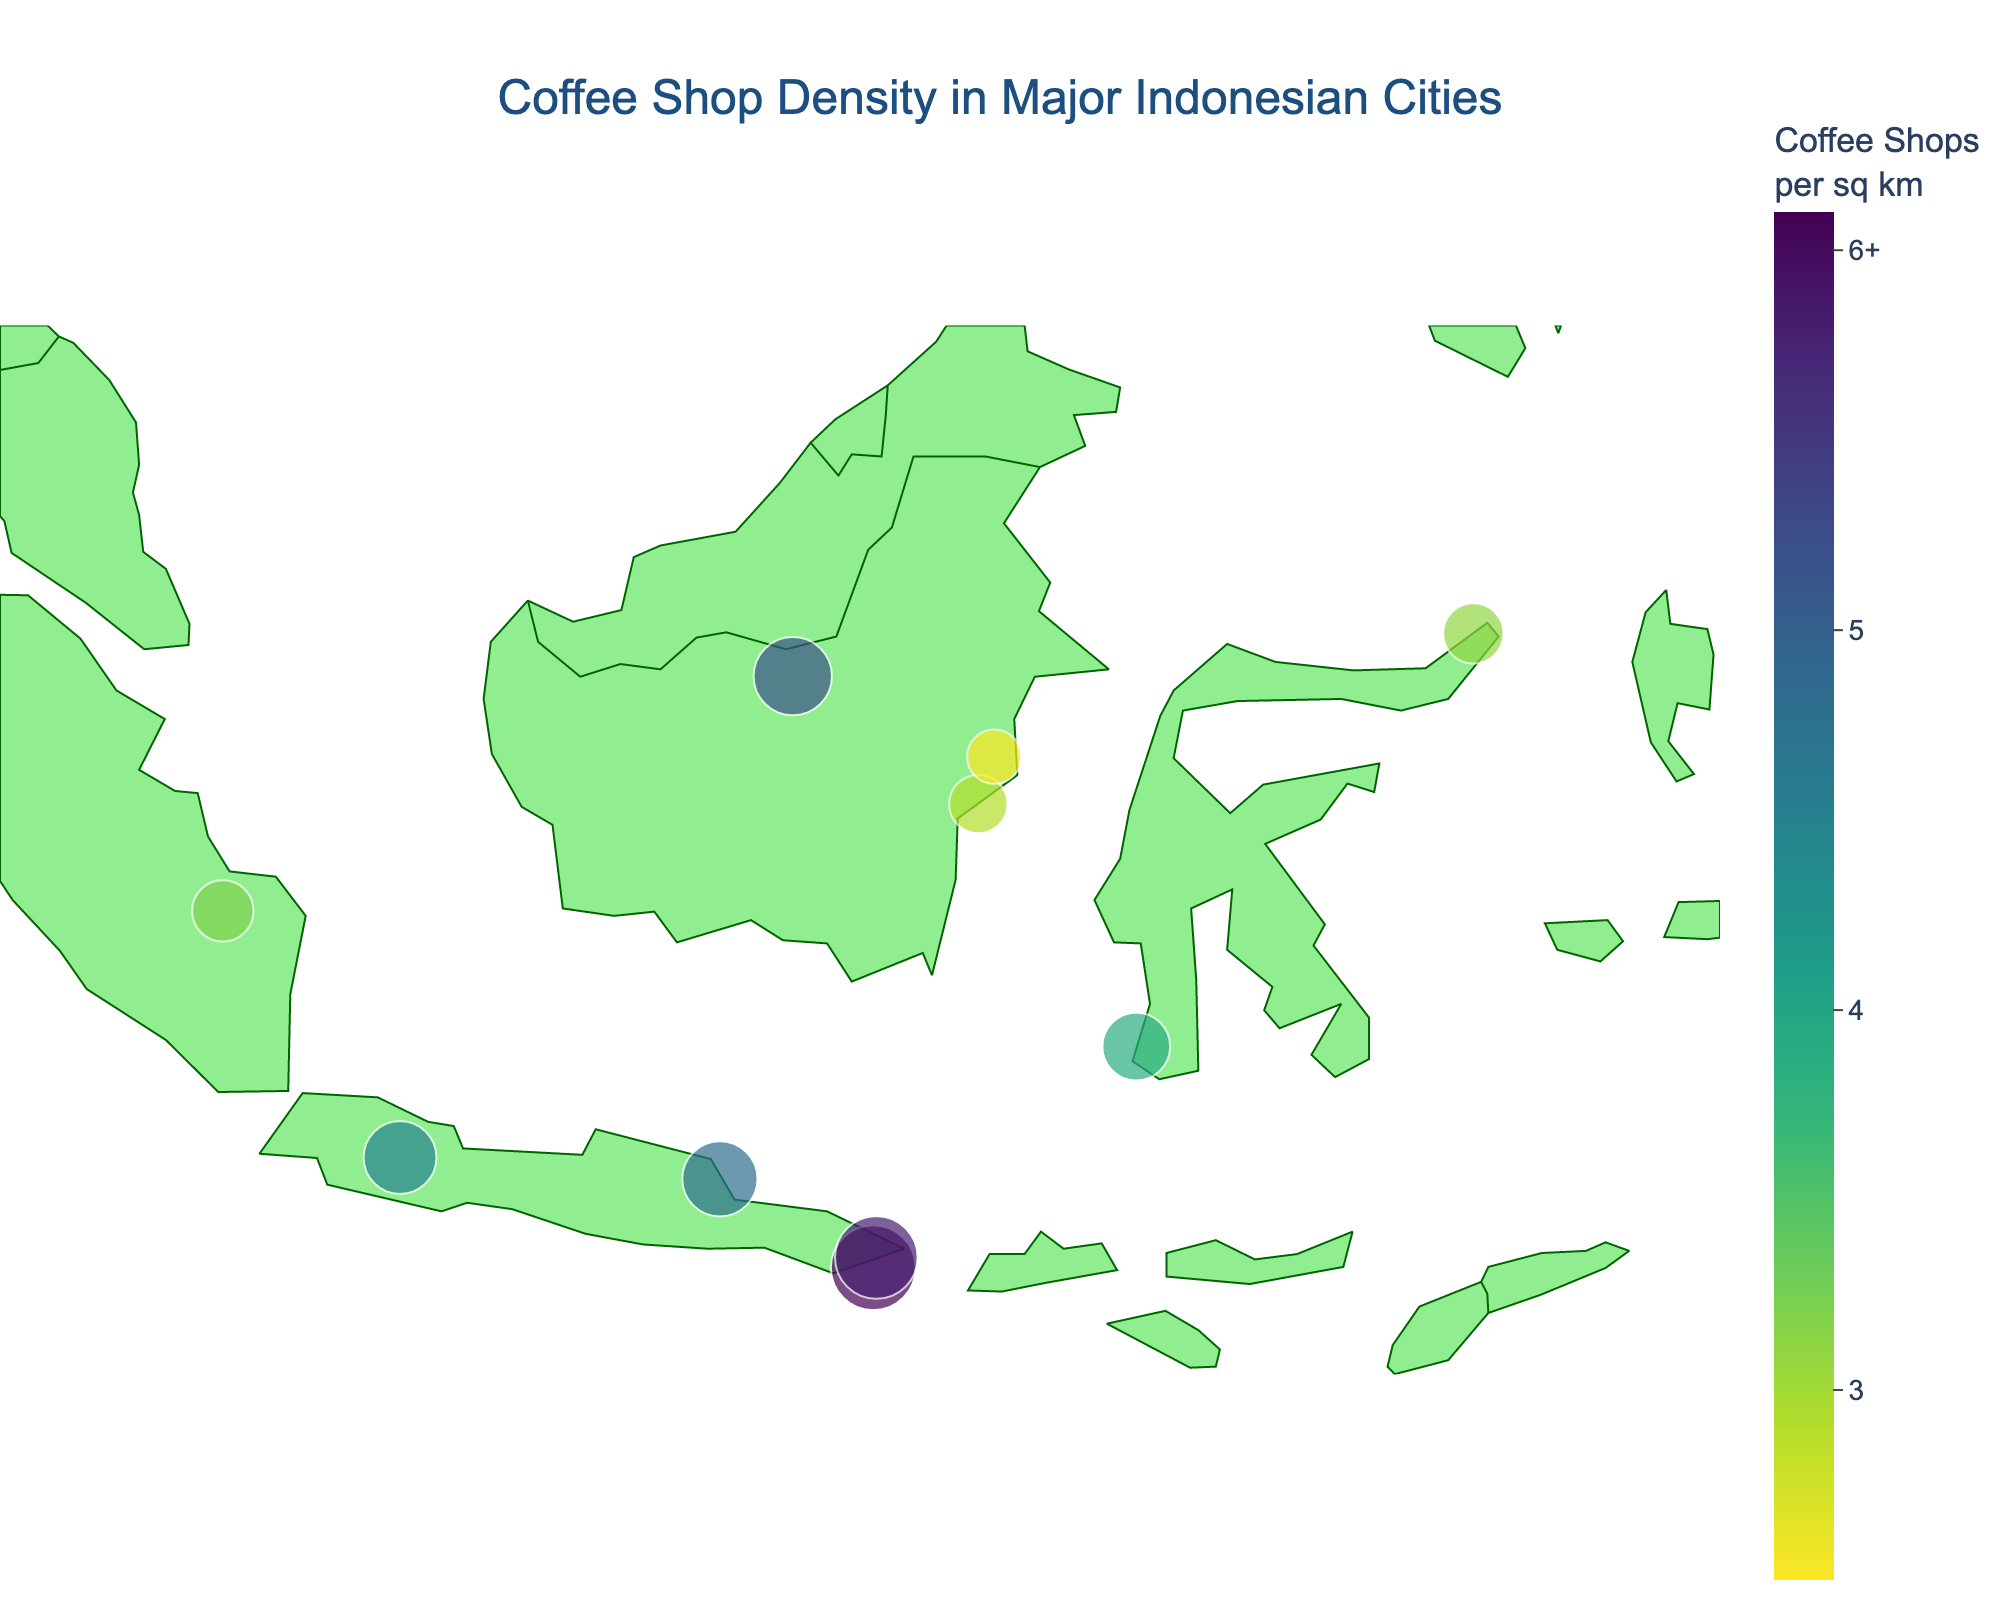How many cities are shown on the plot? Counting the number of city labels on the plot gives us the total number of cities represented.
Answer: 11 Which city has the highest density of coffee shops per square kilometer? The plot's size and color intensity can help identify which city has the highest density. Denpasar on Bali stands out with the largest and darkest marker.
Answer: Denpasar How does the coffee shop density in Jakarta compare to Surabaya? Comparing the size and color of Jakarta's and Surabaya's markers will show if Jakarta has more or fewer coffee shops per square kilometer. Jakarta has a slightly larger and darker marker.
Answer: Jakarta has a higher density What is the difference in coffee shop density between Denpasar and Ubud? Subtract the density value of Ubud from that of Denpasar. Denpasar has 6.1 and Ubud has 5.8 coffee shops per square kilometer.
Answer: 0.3 Which island has more cities represented on the plot, Java or Sumatra? Count the number of cities marked on Java and Sumatra. Java has Jakarta, Surabaya, and Bandung while Sumatra has Medan and Palembang.
Answer: Java What is the average coffee shop density for cities on Sulawesi? Sum the densities of Makassar (3.9) and Manado (3.1), then divide by the number of cities (2). (3.9 + 3.1) / 2 = 3.5
Answer: 3.5 Which city on Sumatra has a lower coffee shop density? Compare the markers for Medan and Palembang. Palembang has a lower density than Medan.
Answer: Palembang Which island's city has the second highest coffee shop density? Look for the city with the second largest and darkest marker after Denpasar. Ubud on Bali is next.
Answer: Bali (Ubud) How many islands have cities with a coffee shop density of 4.5 or higher? Identify and count the islands with cities where the density is 4.5 or more. Java (Jakarta, Surabaya, Bandung) and Bali (Denpasar, Ubud) meet the criteria.
Answer: 2 What is the coffee shop density of the city with the smallest marker? Look for the smallest and least intense marker. Samarinda on Kalimantan has a marker corresponding to 2.5 coffee shops per square kilometer.
Answer: 2.5 